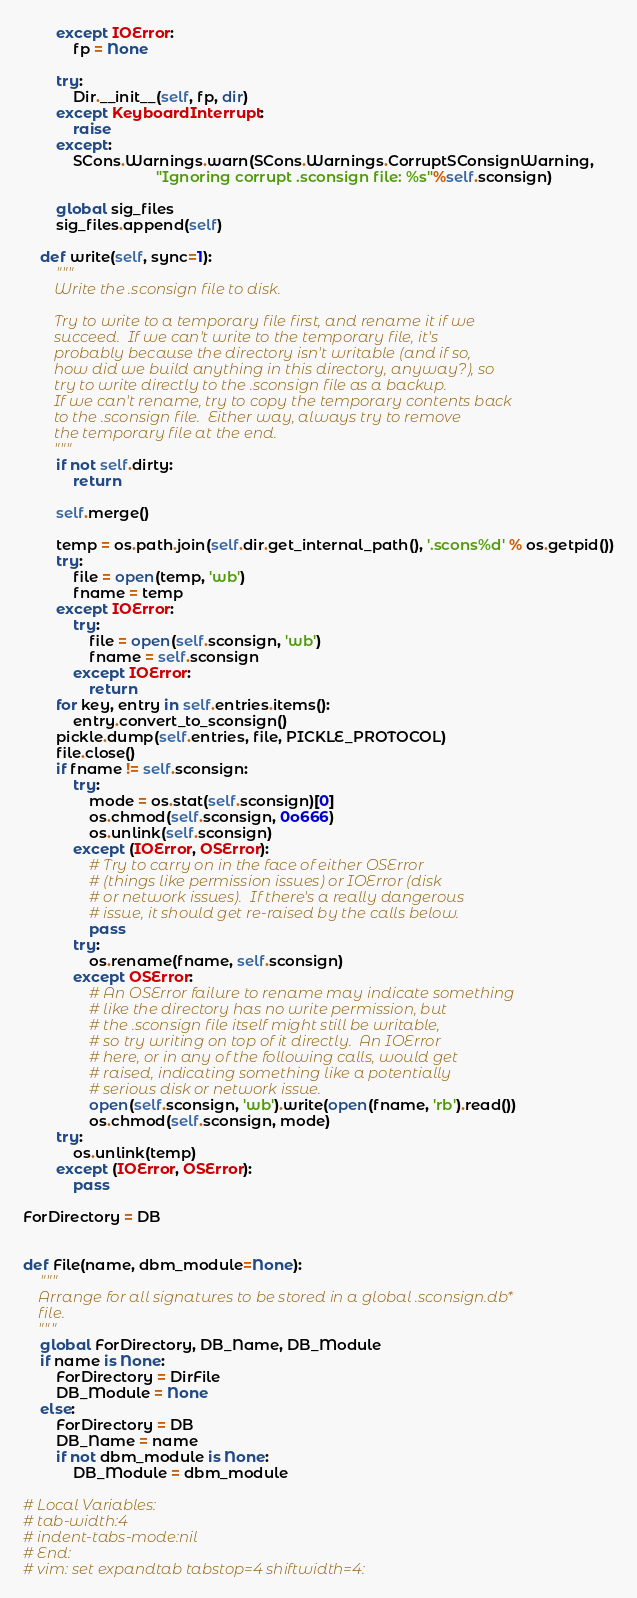Convert code to text. <code><loc_0><loc_0><loc_500><loc_500><_Python_>        except IOError:
            fp = None

        try:
            Dir.__init__(self, fp, dir)
        except KeyboardInterrupt:
            raise
        except:
            SCons.Warnings.warn(SCons.Warnings.CorruptSConsignWarning,
                                "Ignoring corrupt .sconsign file: %s"%self.sconsign)

        global sig_files
        sig_files.append(self)

    def write(self, sync=1):
        """
        Write the .sconsign file to disk.

        Try to write to a temporary file first, and rename it if we
        succeed.  If we can't write to the temporary file, it's
        probably because the directory isn't writable (and if so,
        how did we build anything in this directory, anyway?), so
        try to write directly to the .sconsign file as a backup.
        If we can't rename, try to copy the temporary contents back
        to the .sconsign file.  Either way, always try to remove
        the temporary file at the end.
        """
        if not self.dirty:
            return

        self.merge()

        temp = os.path.join(self.dir.get_internal_path(), '.scons%d' % os.getpid())
        try:
            file = open(temp, 'wb')
            fname = temp
        except IOError:
            try:
                file = open(self.sconsign, 'wb')
                fname = self.sconsign
            except IOError:
                return
        for key, entry in self.entries.items():
            entry.convert_to_sconsign()
        pickle.dump(self.entries, file, PICKLE_PROTOCOL)
        file.close()
        if fname != self.sconsign:
            try:
                mode = os.stat(self.sconsign)[0]
                os.chmod(self.sconsign, 0o666)
                os.unlink(self.sconsign)
            except (IOError, OSError):
                # Try to carry on in the face of either OSError
                # (things like permission issues) or IOError (disk
                # or network issues).  If there's a really dangerous
                # issue, it should get re-raised by the calls below.
                pass
            try:
                os.rename(fname, self.sconsign)
            except OSError:
                # An OSError failure to rename may indicate something
                # like the directory has no write permission, but
                # the .sconsign file itself might still be writable,
                # so try writing on top of it directly.  An IOError
                # here, or in any of the following calls, would get
                # raised, indicating something like a potentially
                # serious disk or network issue.
                open(self.sconsign, 'wb').write(open(fname, 'rb').read())
                os.chmod(self.sconsign, mode)
        try:
            os.unlink(temp)
        except (IOError, OSError):
            pass

ForDirectory = DB


def File(name, dbm_module=None):
    """
    Arrange for all signatures to be stored in a global .sconsign.db*
    file.
    """
    global ForDirectory, DB_Name, DB_Module
    if name is None:
        ForDirectory = DirFile
        DB_Module = None
    else:
        ForDirectory = DB
        DB_Name = name
        if not dbm_module is None:
            DB_Module = dbm_module

# Local Variables:
# tab-width:4
# indent-tabs-mode:nil
# End:
# vim: set expandtab tabstop=4 shiftwidth=4:
</code> 